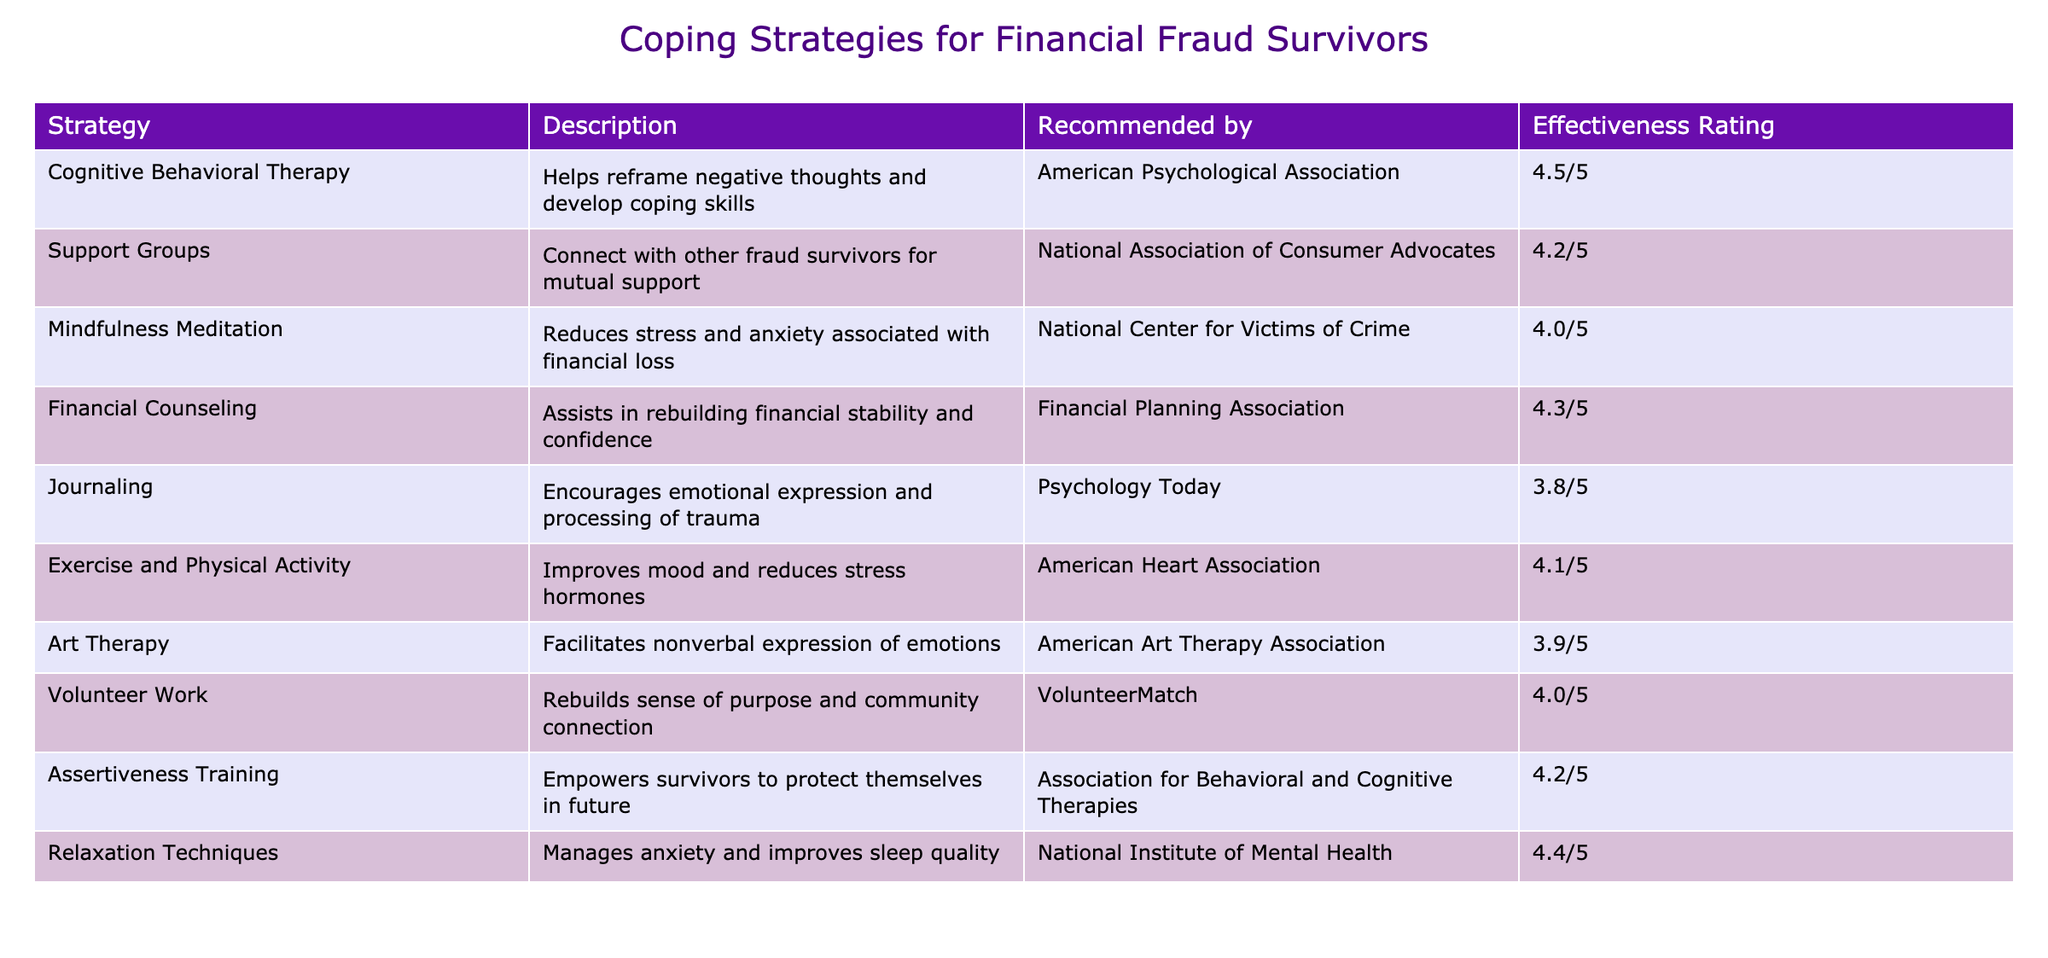What is the effectiveness rating of Cognitive Behavioral Therapy? The effectiveness rating of Cognitive Behavioral Therapy can be found in the table under the "Effectiveness Rating" column next to its entry. It is listed as 4.5/5.
Answer: 4.5/5 Which strategy has the lowest effectiveness rating? To find the strategy with the lowest effectiveness rating, I compare the ratings in the "Effectiveness Rating" column. Journaling has the lowest rating of 3.8/5.
Answer: Journaling Is Financial Counseling recommended by the National Association of Consumer Advocates? Checking the "Recommended by" column for Financial Counseling indicates that it is actually recommended by the Financial Planning Association, not the National Association of Consumer Advocates. Therefore, this statement is false.
Answer: No What is the average effectiveness rating of the strategies in the table? First, I sum all the effectiveness ratings (4.5 + 4.2 + 4.0 + 4.3 + 3.8 + 4.1 + 3.9 + 4.0 + 4.2 + 4.4 = 43.6). Then, I divide the total by the number of strategies (10), resulting in an average of 43.6/10 = 4.36.
Answer: 4.36 Do any strategies have an effectiveness rating of 4.0 or lower? I examine the "Effectiveness Rating" column to identify any ratings of 4.0 or lower. Journaling (3.8), Art Therapy (3.9), and Mindfulness Meditation (4.0) are noted. Thus, the answer is yes.
Answer: Yes Which two strategies have the same effectiveness rating? I look through the "Effectiveness Rating" column to check for matching ratings. No two strategies share the same rating; each rating is unique.
Answer: No What is the purpose of Assertiveness Training according to the table? The table describes the purpose of Assertiveness Training as empowering survivors to protect themselves in the future. This can be directly found in the "Description" column next to Assertiveness Training.
Answer: Empowerment for protection How many strategies focus on stress reduction? To identify the number of strategies that focus on stress reduction, I need to review the descriptions. Mindfulness Meditation, Exercise and Physical Activity, and Relaxation Techniques all emphasize stress reduction. This totals to three strategies.
Answer: 3 Are Support Groups more effective than Journaling? I compare the effectiveness ratings of Support Groups (4.2/5) and Journaling (3.8/5). Since 4.2 is greater than 3.8, Support Groups are indeed more effective.
Answer: Yes 